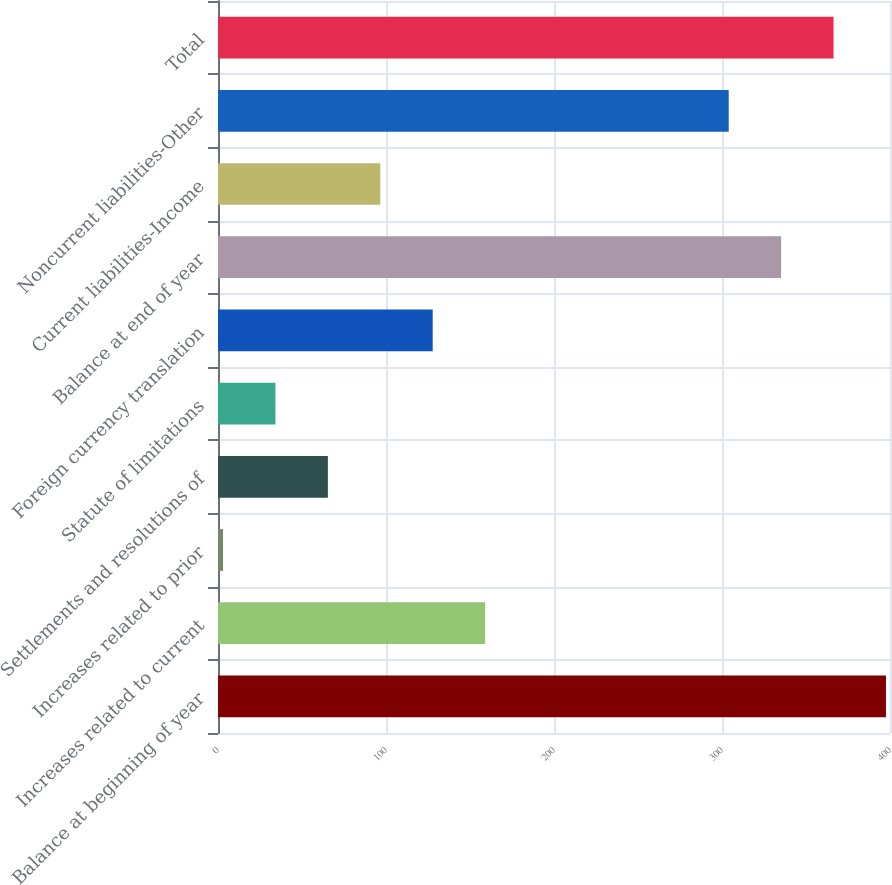Convert chart to OTSL. <chart><loc_0><loc_0><loc_500><loc_500><bar_chart><fcel>Balance at beginning of year<fcel>Increases related to current<fcel>Increases related to prior<fcel>Settlements and resolutions of<fcel>Statute of limitations<fcel>Foreign currency translation<fcel>Balance at end of year<fcel>Current liabilities-Income<fcel>Noncurrent liabilities-Other<fcel>Total<nl><fcel>397.6<fcel>159<fcel>3<fcel>65.4<fcel>34.2<fcel>127.8<fcel>335.2<fcel>96.6<fcel>304<fcel>366.4<nl></chart> 